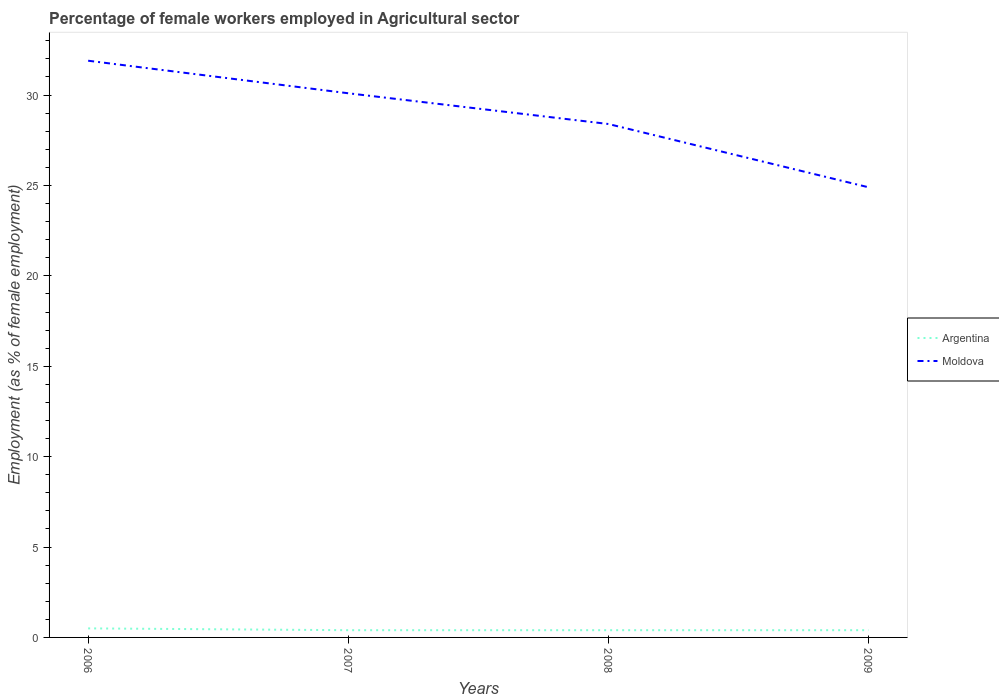Across all years, what is the maximum percentage of females employed in Agricultural sector in Argentina?
Your response must be concise. 0.4. What is the total percentage of females employed in Agricultural sector in Argentina in the graph?
Offer a very short reply. 0. What is the difference between the highest and the second highest percentage of females employed in Agricultural sector in Argentina?
Provide a succinct answer. 0.1. What is the difference between the highest and the lowest percentage of females employed in Agricultural sector in Moldova?
Your answer should be very brief. 2. How many lines are there?
Offer a terse response. 2. How many years are there in the graph?
Make the answer very short. 4. Does the graph contain any zero values?
Your response must be concise. No. How many legend labels are there?
Provide a short and direct response. 2. How are the legend labels stacked?
Offer a very short reply. Vertical. What is the title of the graph?
Make the answer very short. Percentage of female workers employed in Agricultural sector. Does "Bhutan" appear as one of the legend labels in the graph?
Your answer should be compact. No. What is the label or title of the Y-axis?
Your answer should be very brief. Employment (as % of female employment). What is the Employment (as % of female employment) in Moldova in 2006?
Your answer should be compact. 31.9. What is the Employment (as % of female employment) of Argentina in 2007?
Your response must be concise. 0.4. What is the Employment (as % of female employment) of Moldova in 2007?
Your response must be concise. 30.1. What is the Employment (as % of female employment) of Argentina in 2008?
Your answer should be very brief. 0.4. What is the Employment (as % of female employment) of Moldova in 2008?
Offer a very short reply. 28.4. What is the Employment (as % of female employment) in Argentina in 2009?
Offer a terse response. 0.4. What is the Employment (as % of female employment) of Moldova in 2009?
Keep it short and to the point. 24.9. Across all years, what is the maximum Employment (as % of female employment) in Moldova?
Ensure brevity in your answer.  31.9. Across all years, what is the minimum Employment (as % of female employment) in Argentina?
Offer a very short reply. 0.4. Across all years, what is the minimum Employment (as % of female employment) of Moldova?
Provide a succinct answer. 24.9. What is the total Employment (as % of female employment) in Moldova in the graph?
Provide a succinct answer. 115.3. What is the difference between the Employment (as % of female employment) in Argentina in 2006 and that in 2007?
Your response must be concise. 0.1. What is the difference between the Employment (as % of female employment) in Argentina in 2006 and that in 2008?
Your answer should be very brief. 0.1. What is the difference between the Employment (as % of female employment) of Moldova in 2006 and that in 2008?
Provide a short and direct response. 3.5. What is the difference between the Employment (as % of female employment) of Moldova in 2006 and that in 2009?
Ensure brevity in your answer.  7. What is the difference between the Employment (as % of female employment) in Moldova in 2007 and that in 2008?
Your response must be concise. 1.7. What is the difference between the Employment (as % of female employment) of Argentina in 2007 and that in 2009?
Ensure brevity in your answer.  0. What is the difference between the Employment (as % of female employment) in Argentina in 2008 and that in 2009?
Your answer should be very brief. 0. What is the difference between the Employment (as % of female employment) in Argentina in 2006 and the Employment (as % of female employment) in Moldova in 2007?
Provide a short and direct response. -29.6. What is the difference between the Employment (as % of female employment) of Argentina in 2006 and the Employment (as % of female employment) of Moldova in 2008?
Your answer should be very brief. -27.9. What is the difference between the Employment (as % of female employment) in Argentina in 2006 and the Employment (as % of female employment) in Moldova in 2009?
Offer a terse response. -24.4. What is the difference between the Employment (as % of female employment) of Argentina in 2007 and the Employment (as % of female employment) of Moldova in 2009?
Ensure brevity in your answer.  -24.5. What is the difference between the Employment (as % of female employment) in Argentina in 2008 and the Employment (as % of female employment) in Moldova in 2009?
Your answer should be compact. -24.5. What is the average Employment (as % of female employment) in Argentina per year?
Your answer should be very brief. 0.42. What is the average Employment (as % of female employment) of Moldova per year?
Make the answer very short. 28.82. In the year 2006, what is the difference between the Employment (as % of female employment) of Argentina and Employment (as % of female employment) of Moldova?
Your answer should be compact. -31.4. In the year 2007, what is the difference between the Employment (as % of female employment) in Argentina and Employment (as % of female employment) in Moldova?
Your response must be concise. -29.7. In the year 2009, what is the difference between the Employment (as % of female employment) of Argentina and Employment (as % of female employment) of Moldova?
Ensure brevity in your answer.  -24.5. What is the ratio of the Employment (as % of female employment) in Argentina in 2006 to that in 2007?
Provide a succinct answer. 1.25. What is the ratio of the Employment (as % of female employment) in Moldova in 2006 to that in 2007?
Your answer should be compact. 1.06. What is the ratio of the Employment (as % of female employment) in Argentina in 2006 to that in 2008?
Your answer should be compact. 1.25. What is the ratio of the Employment (as % of female employment) in Moldova in 2006 to that in 2008?
Provide a short and direct response. 1.12. What is the ratio of the Employment (as % of female employment) in Moldova in 2006 to that in 2009?
Offer a terse response. 1.28. What is the ratio of the Employment (as % of female employment) in Moldova in 2007 to that in 2008?
Give a very brief answer. 1.06. What is the ratio of the Employment (as % of female employment) in Argentina in 2007 to that in 2009?
Provide a short and direct response. 1. What is the ratio of the Employment (as % of female employment) of Moldova in 2007 to that in 2009?
Give a very brief answer. 1.21. What is the ratio of the Employment (as % of female employment) of Moldova in 2008 to that in 2009?
Provide a short and direct response. 1.14. What is the difference between the highest and the lowest Employment (as % of female employment) of Argentina?
Provide a succinct answer. 0.1. What is the difference between the highest and the lowest Employment (as % of female employment) in Moldova?
Your response must be concise. 7. 